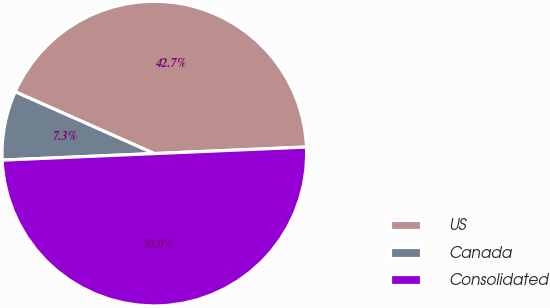Convert chart. <chart><loc_0><loc_0><loc_500><loc_500><pie_chart><fcel>US<fcel>Canada<fcel>Consolidated<nl><fcel>42.66%<fcel>7.34%<fcel>50.0%<nl></chart> 